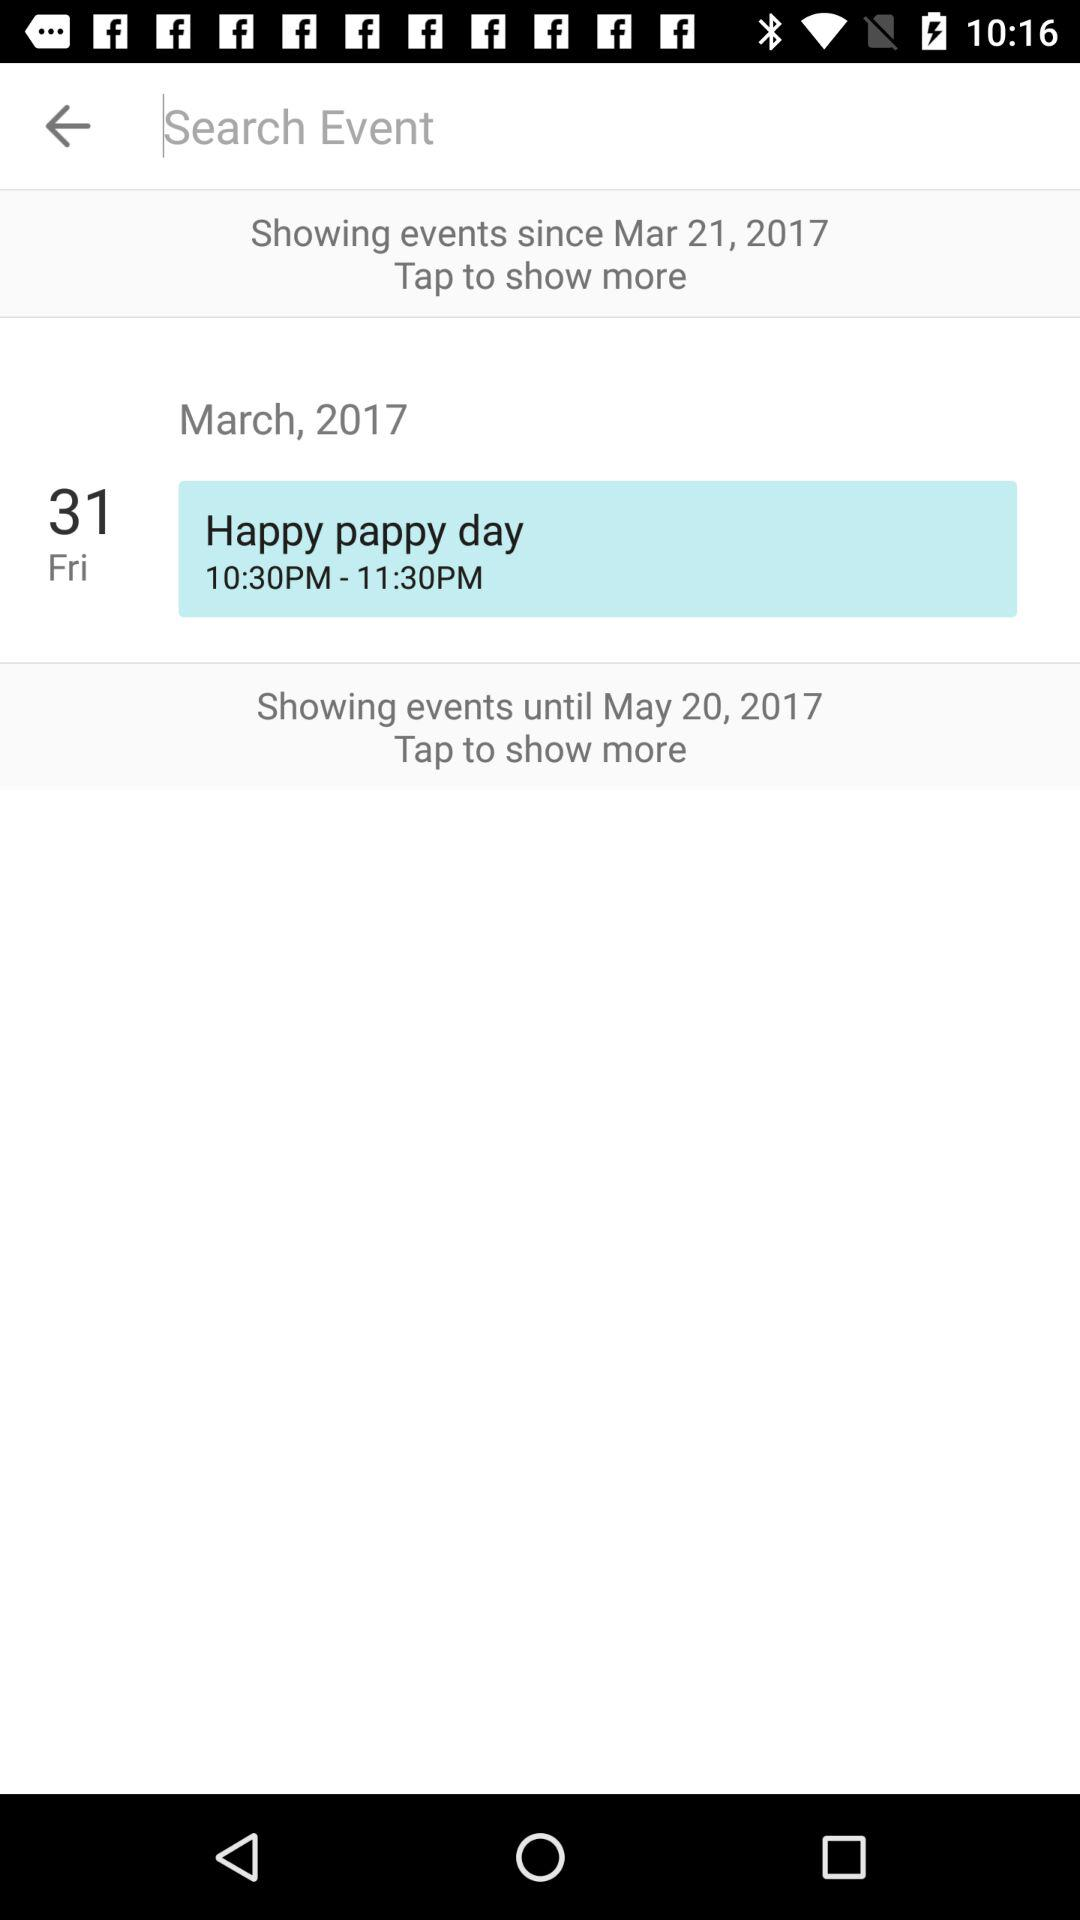What is the last date till events are shown? The events run until May 20, 2017. 